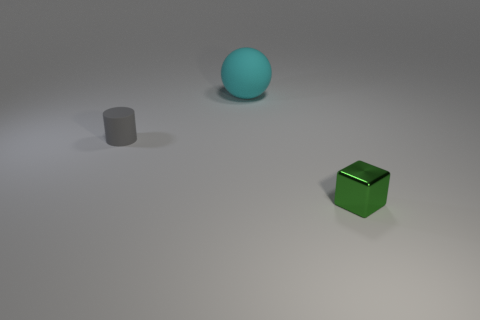Subtract all yellow cubes. Subtract all purple spheres. How many cubes are left? 1 Add 2 large cyan rubber cubes. How many objects exist? 5 Subtract all cubes. How many objects are left? 2 Add 1 gray cylinders. How many gray cylinders exist? 2 Subtract 0 purple balls. How many objects are left? 3 Subtract all tiny gray cylinders. Subtract all tiny things. How many objects are left? 0 Add 2 balls. How many balls are left? 3 